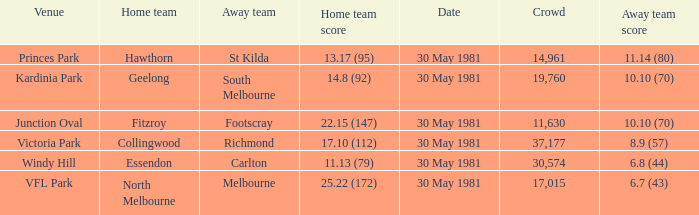What did carlton score while away? 6.8 (44). 